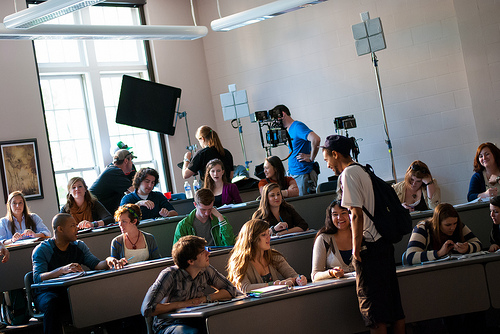<image>
Is the man in front of the woman? Yes. The man is positioned in front of the woman, appearing closer to the camera viewpoint. 